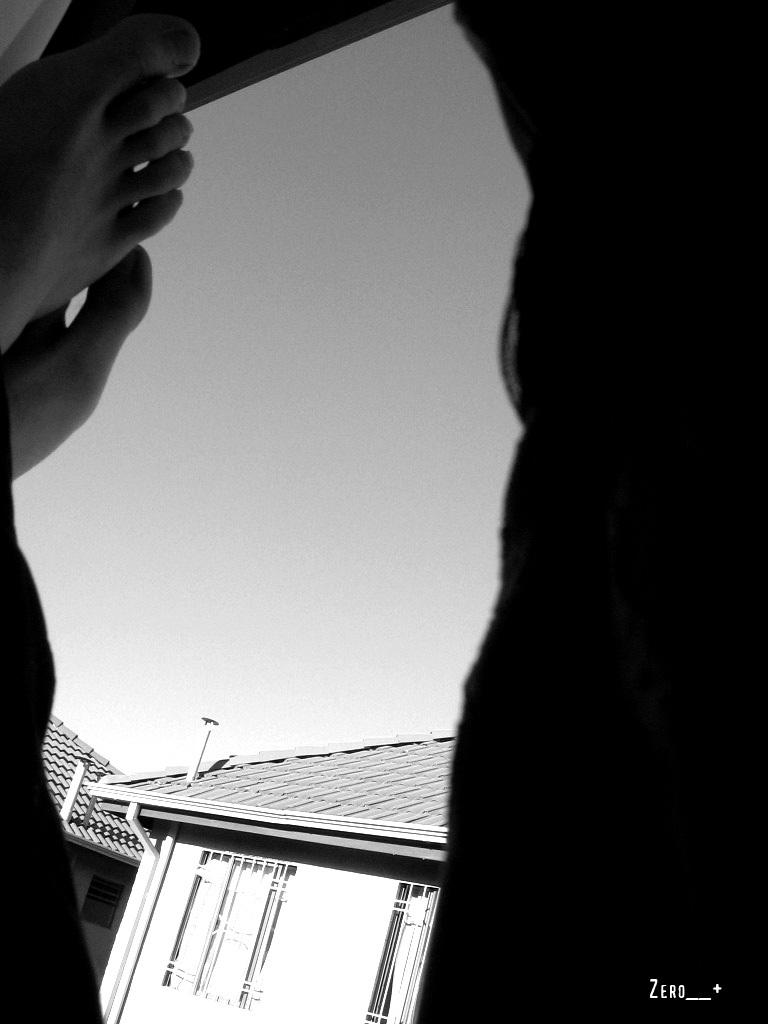What is the color scheme of the image? The image is black and white. What part of a person can be seen in the image? There are legs of a person in the image. What type of structures are present in the image? There are buildings in the image. What can be seen in the background of the image? The sky is visible in the background of the image. How many balloons are being held by the person in the image? There are no balloons visible in the image. What type of property is being sold in the image? There is no property being sold in the image. 